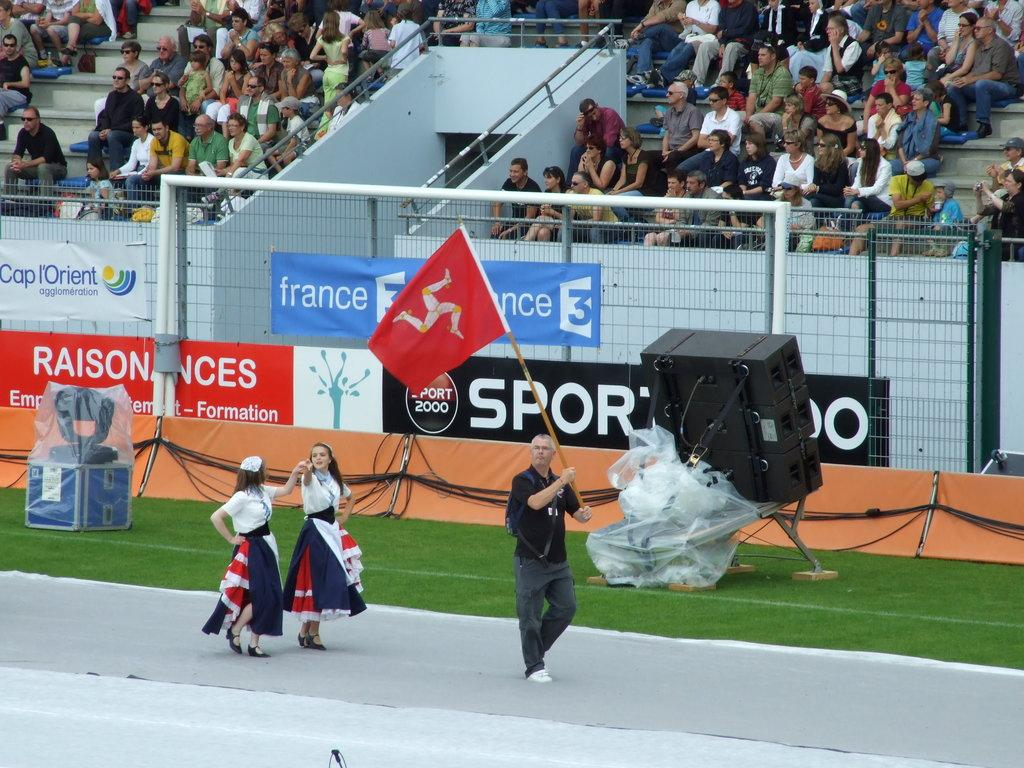<image>
Create a compact narrative representing the image presented. Women in traditional dresses follow a man with a flag on a track with signs that say france. 